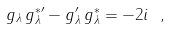<formula> <loc_0><loc_0><loc_500><loc_500>g _ { \lambda } \, g _ { \lambda } ^ { * \prime } - g _ { \lambda } ^ { \prime } \, g _ { \lambda } ^ { * } = - 2 i \ ,</formula> 